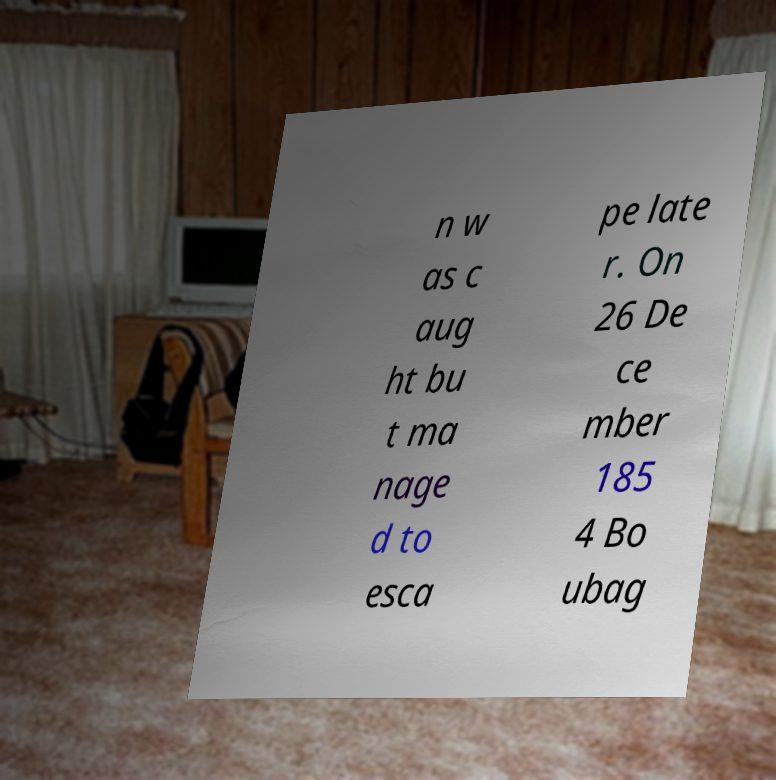I need the written content from this picture converted into text. Can you do that? n w as c aug ht bu t ma nage d to esca pe late r. On 26 De ce mber 185 4 Bo ubag 